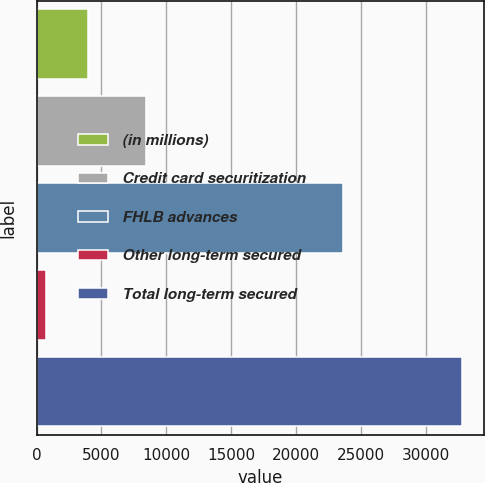<chart> <loc_0><loc_0><loc_500><loc_500><bar_chart><fcel>(in millions)<fcel>Credit card securitization<fcel>FHLB advances<fcel>Other long-term secured<fcel>Total long-term secured<nl><fcel>3959.4<fcel>8434<fcel>23650<fcel>751<fcel>32835<nl></chart> 